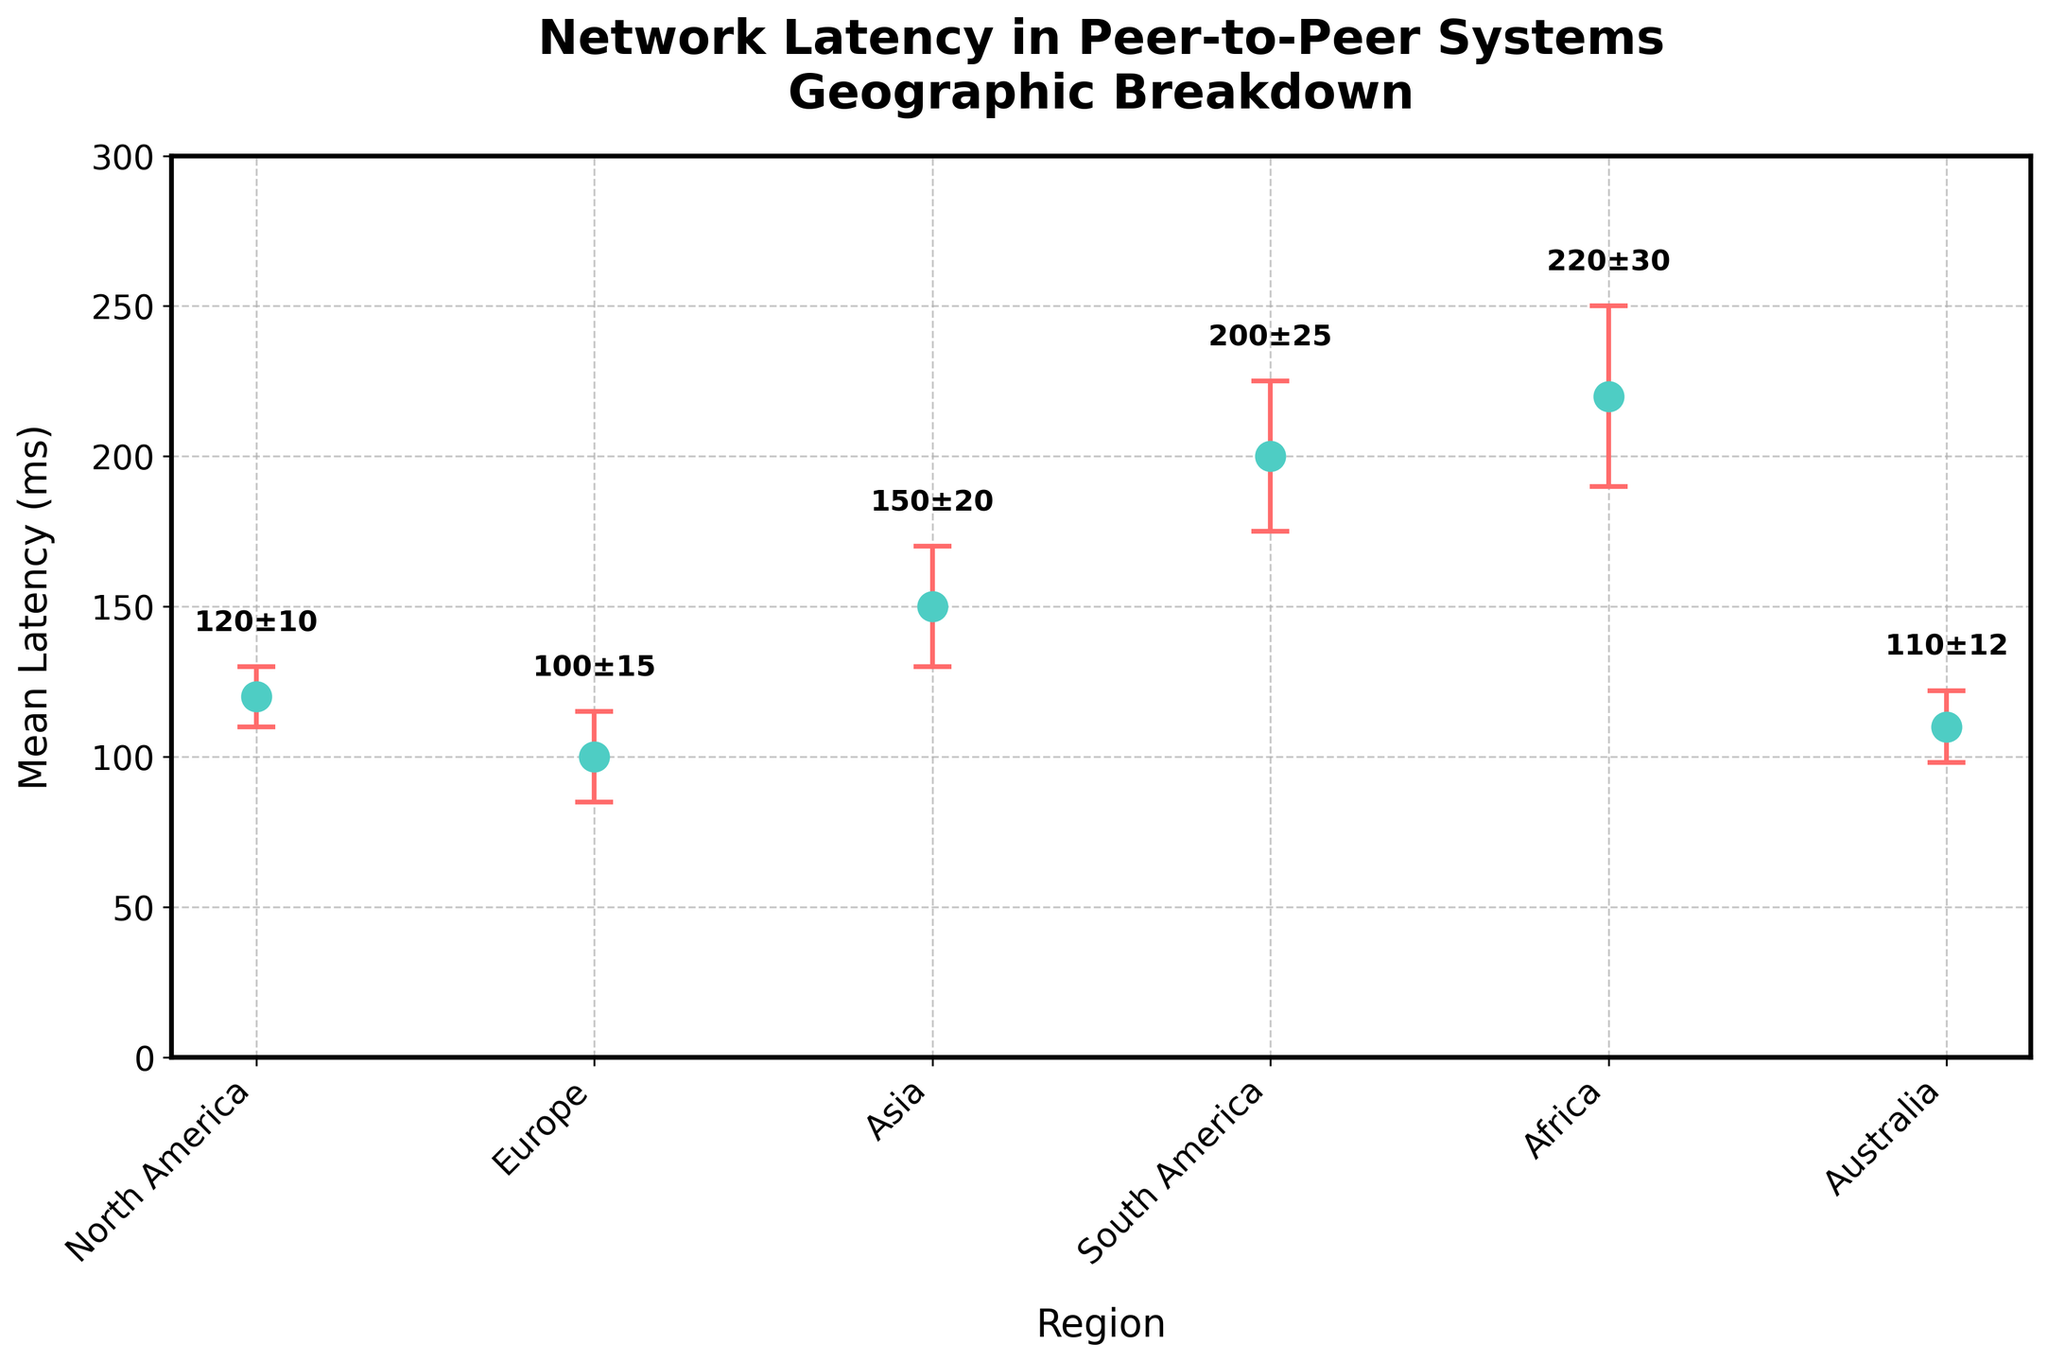What is the title of the plot? The title is typically placed at the top of the plot, and in this case, it reads 'Network Latency in Peer-to-Peer Systems Geographic Breakdown'.
Answer: Network Latency in Peer-to-Peer Systems Geographic Breakdown What is the mean latency in North America? Locate the point corresponding to North America on the x-axis and read the associated y-value. The mean latency for North America is 120 ms.
Answer: 120 ms Which region has the highest mean latency? Compare the y-values for all regions and identify the highest one. Africa has the highest mean latency at 220 ms.
Answer: Africa What is the error bar value for Asia? Identify the point for Asia and check the length of the error bar associated with it. The error bar value is the ± value listed for Asia, which is 20 ms.
Answer: 20 ms What is the difference in mean latency between Europe and South America? Find the mean latencies for Europe (100 ms) and South America (200 ms). Subtract the smaller value from the larger one: 200 - 100 = 100 ms.
Answer: 100 ms What is the range of latencies including error bars? Identify the highest mean plus error (Africa: 220 + 30 = 250 ms) and the lowest mean minus error (Europe: 100 - 15 = 85 ms). The range is from 85 to 250 ms.
Answer: 85 to 250 ms What regions have mean latencies within 10 ms of Australia's mean latency? Australia's mean latency is 110 ms. Check other regions to see which fall within 100 to 120 ms. North America (120 ms) is within this range.
Answer: North America What is the mean of the mean latencies for all regions? Add the mean latencies for all regions and divide by the number of regions: (120 + 100 + 150 + 200 + 220 + 110) / 6 = 150 ms.
Answer: 150 ms How does the mean latency in Australia compare to the mean latency in North America? Compare the two mean latencies: North America is 120 ms and Australia is 110 ms. Australia's mean latency is 10 ms less than North America's.
Answer: Australia's mean latency is 10 ms less What is the total range of standard errors across all regions? Identify the maximum error (30 ms in Africa) and the minimum error (10 ms in North America). The range is 30 - 10 = 20 ms.
Answer: 20 ms 